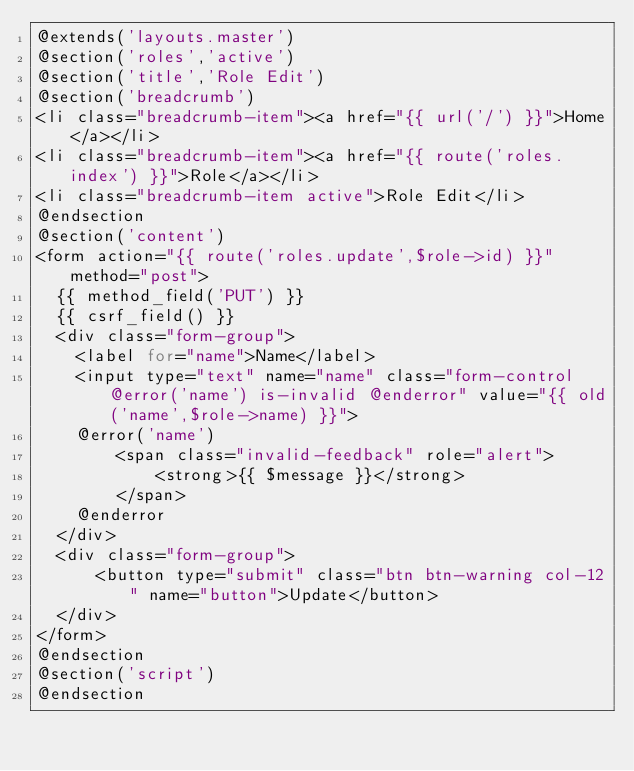Convert code to text. <code><loc_0><loc_0><loc_500><loc_500><_PHP_>@extends('layouts.master')
@section('roles','active')
@section('title','Role Edit')
@section('breadcrumb')
<li class="breadcrumb-item"><a href="{{ url('/') }}">Home</a></li>
<li class="breadcrumb-item"><a href="{{ route('roles.index') }}">Role</a></li>
<li class="breadcrumb-item active">Role Edit</li>
@endsection
@section('content')
<form action="{{ route('roles.update',$role->id) }}" method="post">
  {{ method_field('PUT') }}
  {{ csrf_field() }}
  <div class="form-group">
    <label for="name">Name</label>
    <input type="text" name="name" class="form-control @error('name') is-invalid @enderror" value="{{ old('name',$role->name) }}">
    @error('name')
        <span class="invalid-feedback" role="alert">
            <strong>{{ $message }}</strong>
        </span>
    @enderror
  </div>
  <div class="form-group">
      <button type="submit" class="btn btn-warning col-12" name="button">Update</button>
  </div>
</form>
@endsection
@section('script')
@endsection
</code> 